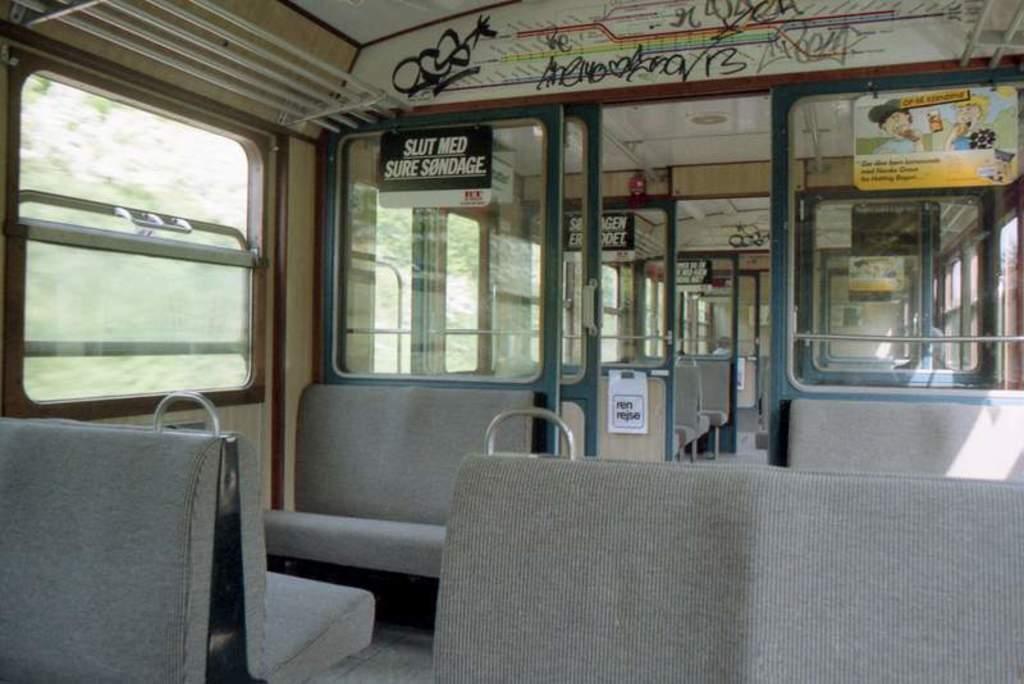Please provide a concise description of this image. This is the picture of a vehicle. Image there are seats and there are boards and there is text on the boards. Behind the windows there are trees. 